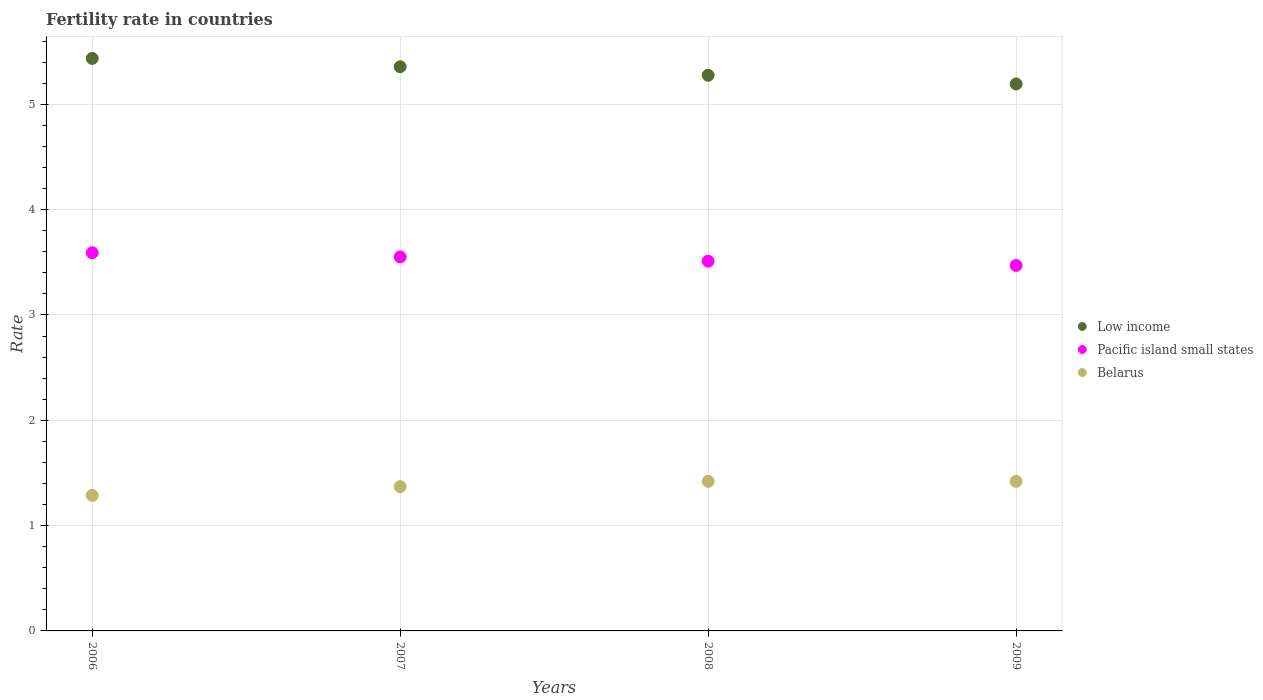How many different coloured dotlines are there?
Your answer should be very brief. 3. Is the number of dotlines equal to the number of legend labels?
Your answer should be very brief. Yes. What is the fertility rate in Belarus in 2008?
Provide a succinct answer. 1.42. Across all years, what is the maximum fertility rate in Pacific island small states?
Provide a short and direct response. 3.59. Across all years, what is the minimum fertility rate in Pacific island small states?
Give a very brief answer. 3.47. In which year was the fertility rate in Pacific island small states minimum?
Keep it short and to the point. 2009. What is the total fertility rate in Pacific island small states in the graph?
Offer a very short reply. 14.12. What is the difference between the fertility rate in Low income in 2006 and that in 2007?
Ensure brevity in your answer.  0.08. What is the difference between the fertility rate in Low income in 2008 and the fertility rate in Belarus in 2007?
Ensure brevity in your answer.  3.91. What is the average fertility rate in Pacific island small states per year?
Offer a terse response. 3.53. In the year 2009, what is the difference between the fertility rate in Belarus and fertility rate in Low income?
Keep it short and to the point. -3.77. In how many years, is the fertility rate in Low income greater than 0.2?
Your answer should be very brief. 4. Is the fertility rate in Belarus in 2008 less than that in 2009?
Offer a terse response. No. Is the difference between the fertility rate in Belarus in 2006 and 2008 greater than the difference between the fertility rate in Low income in 2006 and 2008?
Your response must be concise. No. What is the difference between the highest and the second highest fertility rate in Belarus?
Your answer should be compact. 0. What is the difference between the highest and the lowest fertility rate in Pacific island small states?
Ensure brevity in your answer.  0.12. In how many years, is the fertility rate in Belarus greater than the average fertility rate in Belarus taken over all years?
Make the answer very short. 2. How many years are there in the graph?
Your answer should be compact. 4. Does the graph contain grids?
Your answer should be very brief. Yes. What is the title of the graph?
Offer a very short reply. Fertility rate in countries. What is the label or title of the Y-axis?
Ensure brevity in your answer.  Rate. What is the Rate of Low income in 2006?
Give a very brief answer. 5.44. What is the Rate of Pacific island small states in 2006?
Offer a very short reply. 3.59. What is the Rate of Belarus in 2006?
Your response must be concise. 1.29. What is the Rate in Low income in 2007?
Give a very brief answer. 5.36. What is the Rate in Pacific island small states in 2007?
Ensure brevity in your answer.  3.55. What is the Rate of Belarus in 2007?
Your answer should be very brief. 1.37. What is the Rate in Low income in 2008?
Your response must be concise. 5.28. What is the Rate of Pacific island small states in 2008?
Your answer should be compact. 3.51. What is the Rate of Belarus in 2008?
Your answer should be compact. 1.42. What is the Rate in Low income in 2009?
Ensure brevity in your answer.  5.19. What is the Rate in Pacific island small states in 2009?
Ensure brevity in your answer.  3.47. What is the Rate of Belarus in 2009?
Keep it short and to the point. 1.42. Across all years, what is the maximum Rate in Low income?
Keep it short and to the point. 5.44. Across all years, what is the maximum Rate of Pacific island small states?
Make the answer very short. 3.59. Across all years, what is the maximum Rate in Belarus?
Offer a terse response. 1.42. Across all years, what is the minimum Rate of Low income?
Provide a succinct answer. 5.19. Across all years, what is the minimum Rate of Pacific island small states?
Make the answer very short. 3.47. Across all years, what is the minimum Rate in Belarus?
Offer a terse response. 1.29. What is the total Rate of Low income in the graph?
Your answer should be compact. 21.26. What is the total Rate in Pacific island small states in the graph?
Offer a terse response. 14.12. What is the total Rate in Belarus in the graph?
Your answer should be very brief. 5.5. What is the difference between the Rate of Low income in 2006 and that in 2007?
Offer a very short reply. 0.08. What is the difference between the Rate in Pacific island small states in 2006 and that in 2007?
Provide a succinct answer. 0.04. What is the difference between the Rate in Belarus in 2006 and that in 2007?
Provide a short and direct response. -0.08. What is the difference between the Rate of Low income in 2006 and that in 2008?
Provide a short and direct response. 0.16. What is the difference between the Rate in Pacific island small states in 2006 and that in 2008?
Ensure brevity in your answer.  0.08. What is the difference between the Rate in Belarus in 2006 and that in 2008?
Your answer should be compact. -0.13. What is the difference between the Rate of Low income in 2006 and that in 2009?
Offer a terse response. 0.24. What is the difference between the Rate in Pacific island small states in 2006 and that in 2009?
Ensure brevity in your answer.  0.12. What is the difference between the Rate of Belarus in 2006 and that in 2009?
Your response must be concise. -0.13. What is the difference between the Rate of Low income in 2007 and that in 2008?
Your answer should be compact. 0.08. What is the difference between the Rate in Pacific island small states in 2007 and that in 2008?
Provide a short and direct response. 0.04. What is the difference between the Rate in Belarus in 2007 and that in 2008?
Ensure brevity in your answer.  -0.05. What is the difference between the Rate of Low income in 2007 and that in 2009?
Your response must be concise. 0.16. What is the difference between the Rate in Pacific island small states in 2007 and that in 2009?
Keep it short and to the point. 0.08. What is the difference between the Rate in Belarus in 2007 and that in 2009?
Your answer should be very brief. -0.05. What is the difference between the Rate in Low income in 2008 and that in 2009?
Provide a short and direct response. 0.08. What is the difference between the Rate of Pacific island small states in 2008 and that in 2009?
Make the answer very short. 0.04. What is the difference between the Rate of Low income in 2006 and the Rate of Pacific island small states in 2007?
Your answer should be very brief. 1.88. What is the difference between the Rate of Low income in 2006 and the Rate of Belarus in 2007?
Keep it short and to the point. 4.07. What is the difference between the Rate of Pacific island small states in 2006 and the Rate of Belarus in 2007?
Ensure brevity in your answer.  2.22. What is the difference between the Rate in Low income in 2006 and the Rate in Pacific island small states in 2008?
Ensure brevity in your answer.  1.92. What is the difference between the Rate of Low income in 2006 and the Rate of Belarus in 2008?
Give a very brief answer. 4.02. What is the difference between the Rate of Pacific island small states in 2006 and the Rate of Belarus in 2008?
Provide a short and direct response. 2.17. What is the difference between the Rate of Low income in 2006 and the Rate of Pacific island small states in 2009?
Offer a terse response. 1.97. What is the difference between the Rate of Low income in 2006 and the Rate of Belarus in 2009?
Give a very brief answer. 4.02. What is the difference between the Rate in Pacific island small states in 2006 and the Rate in Belarus in 2009?
Give a very brief answer. 2.17. What is the difference between the Rate of Low income in 2007 and the Rate of Pacific island small states in 2008?
Offer a very short reply. 1.85. What is the difference between the Rate in Low income in 2007 and the Rate in Belarus in 2008?
Offer a terse response. 3.94. What is the difference between the Rate in Pacific island small states in 2007 and the Rate in Belarus in 2008?
Provide a short and direct response. 2.13. What is the difference between the Rate of Low income in 2007 and the Rate of Pacific island small states in 2009?
Ensure brevity in your answer.  1.89. What is the difference between the Rate of Low income in 2007 and the Rate of Belarus in 2009?
Provide a succinct answer. 3.94. What is the difference between the Rate of Pacific island small states in 2007 and the Rate of Belarus in 2009?
Provide a succinct answer. 2.13. What is the difference between the Rate of Low income in 2008 and the Rate of Pacific island small states in 2009?
Offer a very short reply. 1.81. What is the difference between the Rate of Low income in 2008 and the Rate of Belarus in 2009?
Offer a terse response. 3.86. What is the difference between the Rate in Pacific island small states in 2008 and the Rate in Belarus in 2009?
Ensure brevity in your answer.  2.09. What is the average Rate in Low income per year?
Your response must be concise. 5.32. What is the average Rate in Pacific island small states per year?
Make the answer very short. 3.53. What is the average Rate in Belarus per year?
Ensure brevity in your answer.  1.37. In the year 2006, what is the difference between the Rate of Low income and Rate of Pacific island small states?
Ensure brevity in your answer.  1.84. In the year 2006, what is the difference between the Rate in Low income and Rate in Belarus?
Your response must be concise. 4.15. In the year 2006, what is the difference between the Rate of Pacific island small states and Rate of Belarus?
Your response must be concise. 2.3. In the year 2007, what is the difference between the Rate of Low income and Rate of Pacific island small states?
Ensure brevity in your answer.  1.81. In the year 2007, what is the difference between the Rate in Low income and Rate in Belarus?
Make the answer very short. 3.99. In the year 2007, what is the difference between the Rate of Pacific island small states and Rate of Belarus?
Provide a short and direct response. 2.18. In the year 2008, what is the difference between the Rate in Low income and Rate in Pacific island small states?
Make the answer very short. 1.77. In the year 2008, what is the difference between the Rate in Low income and Rate in Belarus?
Keep it short and to the point. 3.86. In the year 2008, what is the difference between the Rate of Pacific island small states and Rate of Belarus?
Keep it short and to the point. 2.09. In the year 2009, what is the difference between the Rate in Low income and Rate in Pacific island small states?
Your response must be concise. 1.72. In the year 2009, what is the difference between the Rate in Low income and Rate in Belarus?
Ensure brevity in your answer.  3.77. In the year 2009, what is the difference between the Rate of Pacific island small states and Rate of Belarus?
Offer a terse response. 2.05. What is the ratio of the Rate in Low income in 2006 to that in 2007?
Your answer should be very brief. 1.01. What is the ratio of the Rate of Pacific island small states in 2006 to that in 2007?
Provide a succinct answer. 1.01. What is the ratio of the Rate in Belarus in 2006 to that in 2007?
Give a very brief answer. 0.94. What is the ratio of the Rate of Low income in 2006 to that in 2008?
Make the answer very short. 1.03. What is the ratio of the Rate of Pacific island small states in 2006 to that in 2008?
Make the answer very short. 1.02. What is the ratio of the Rate in Belarus in 2006 to that in 2008?
Your answer should be compact. 0.91. What is the ratio of the Rate in Low income in 2006 to that in 2009?
Your response must be concise. 1.05. What is the ratio of the Rate of Pacific island small states in 2006 to that in 2009?
Ensure brevity in your answer.  1.03. What is the ratio of the Rate in Belarus in 2006 to that in 2009?
Ensure brevity in your answer.  0.91. What is the ratio of the Rate in Low income in 2007 to that in 2008?
Give a very brief answer. 1.02. What is the ratio of the Rate in Pacific island small states in 2007 to that in 2008?
Your response must be concise. 1.01. What is the ratio of the Rate in Belarus in 2007 to that in 2008?
Make the answer very short. 0.96. What is the ratio of the Rate in Low income in 2007 to that in 2009?
Your answer should be compact. 1.03. What is the ratio of the Rate of Pacific island small states in 2007 to that in 2009?
Your answer should be very brief. 1.02. What is the ratio of the Rate of Belarus in 2007 to that in 2009?
Your answer should be very brief. 0.96. What is the ratio of the Rate of Low income in 2008 to that in 2009?
Your answer should be very brief. 1.02. What is the ratio of the Rate of Pacific island small states in 2008 to that in 2009?
Your answer should be very brief. 1.01. What is the difference between the highest and the second highest Rate of Low income?
Your answer should be very brief. 0.08. What is the difference between the highest and the second highest Rate of Pacific island small states?
Your response must be concise. 0.04. What is the difference between the highest and the second highest Rate in Belarus?
Provide a succinct answer. 0. What is the difference between the highest and the lowest Rate of Low income?
Provide a short and direct response. 0.24. What is the difference between the highest and the lowest Rate of Pacific island small states?
Provide a succinct answer. 0.12. What is the difference between the highest and the lowest Rate in Belarus?
Your answer should be very brief. 0.13. 